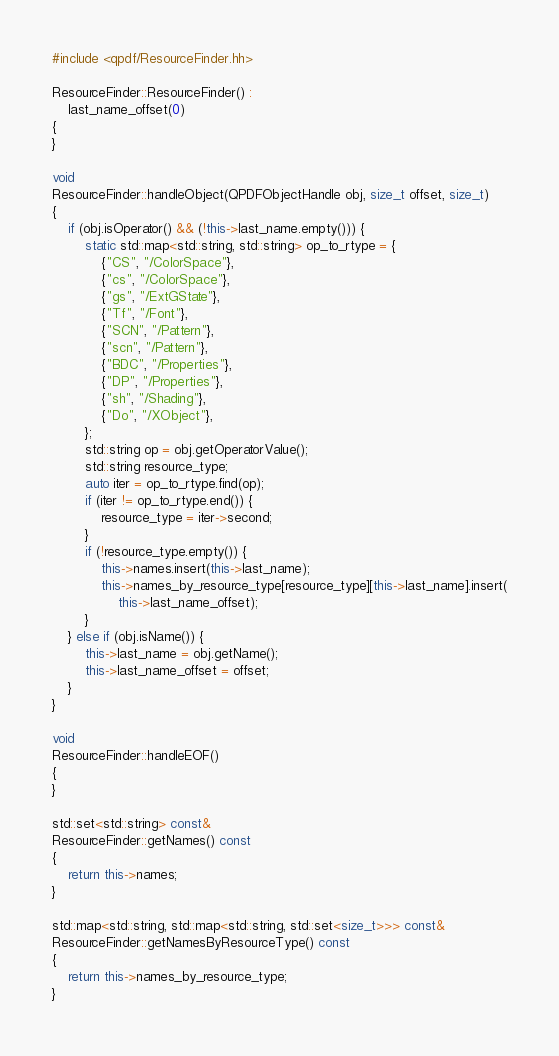Convert code to text. <code><loc_0><loc_0><loc_500><loc_500><_C++_>#include <qpdf/ResourceFinder.hh>

ResourceFinder::ResourceFinder() :
    last_name_offset(0)
{
}

void
ResourceFinder::handleObject(QPDFObjectHandle obj, size_t offset, size_t)
{
    if (obj.isOperator() && (!this->last_name.empty())) {
        static std::map<std::string, std::string> op_to_rtype = {
            {"CS", "/ColorSpace"},
            {"cs", "/ColorSpace"},
            {"gs", "/ExtGState"},
            {"Tf", "/Font"},
            {"SCN", "/Pattern"},
            {"scn", "/Pattern"},
            {"BDC", "/Properties"},
            {"DP", "/Properties"},
            {"sh", "/Shading"},
            {"Do", "/XObject"},
        };
        std::string op = obj.getOperatorValue();
        std::string resource_type;
        auto iter = op_to_rtype.find(op);
        if (iter != op_to_rtype.end()) {
            resource_type = iter->second;
        }
        if (!resource_type.empty()) {
            this->names.insert(this->last_name);
            this->names_by_resource_type[resource_type][this->last_name].insert(
                this->last_name_offset);
        }
    } else if (obj.isName()) {
        this->last_name = obj.getName();
        this->last_name_offset = offset;
    }
}

void
ResourceFinder::handleEOF()
{
}

std::set<std::string> const&
ResourceFinder::getNames() const
{
    return this->names;
}

std::map<std::string, std::map<std::string, std::set<size_t>>> const&
ResourceFinder::getNamesByResourceType() const
{
    return this->names_by_resource_type;
}
</code> 